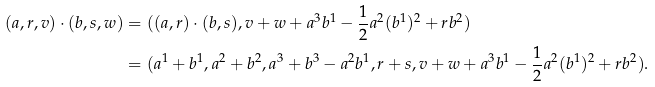Convert formula to latex. <formula><loc_0><loc_0><loc_500><loc_500>( a , r , v ) \cdot ( b , s , w ) & = ( ( a , r ) \cdot ( b , s ) , v + w + a ^ { 3 } b ^ { 1 } - { \frac { 1 } { 2 } } a ^ { 2 } ( b ^ { 1 } ) ^ { 2 } + r b ^ { 2 } ) \\ & = ( a ^ { 1 } + b ^ { 1 } , a ^ { 2 } + b ^ { 2 } , a ^ { 3 } + b ^ { 3 } - a ^ { 2 } b ^ { 1 } , r + s , v + w + a ^ { 3 } b ^ { 1 } - { \frac { 1 } { 2 } } a ^ { 2 } ( b ^ { 1 } ) ^ { 2 } + r b ^ { 2 } ) .</formula> 